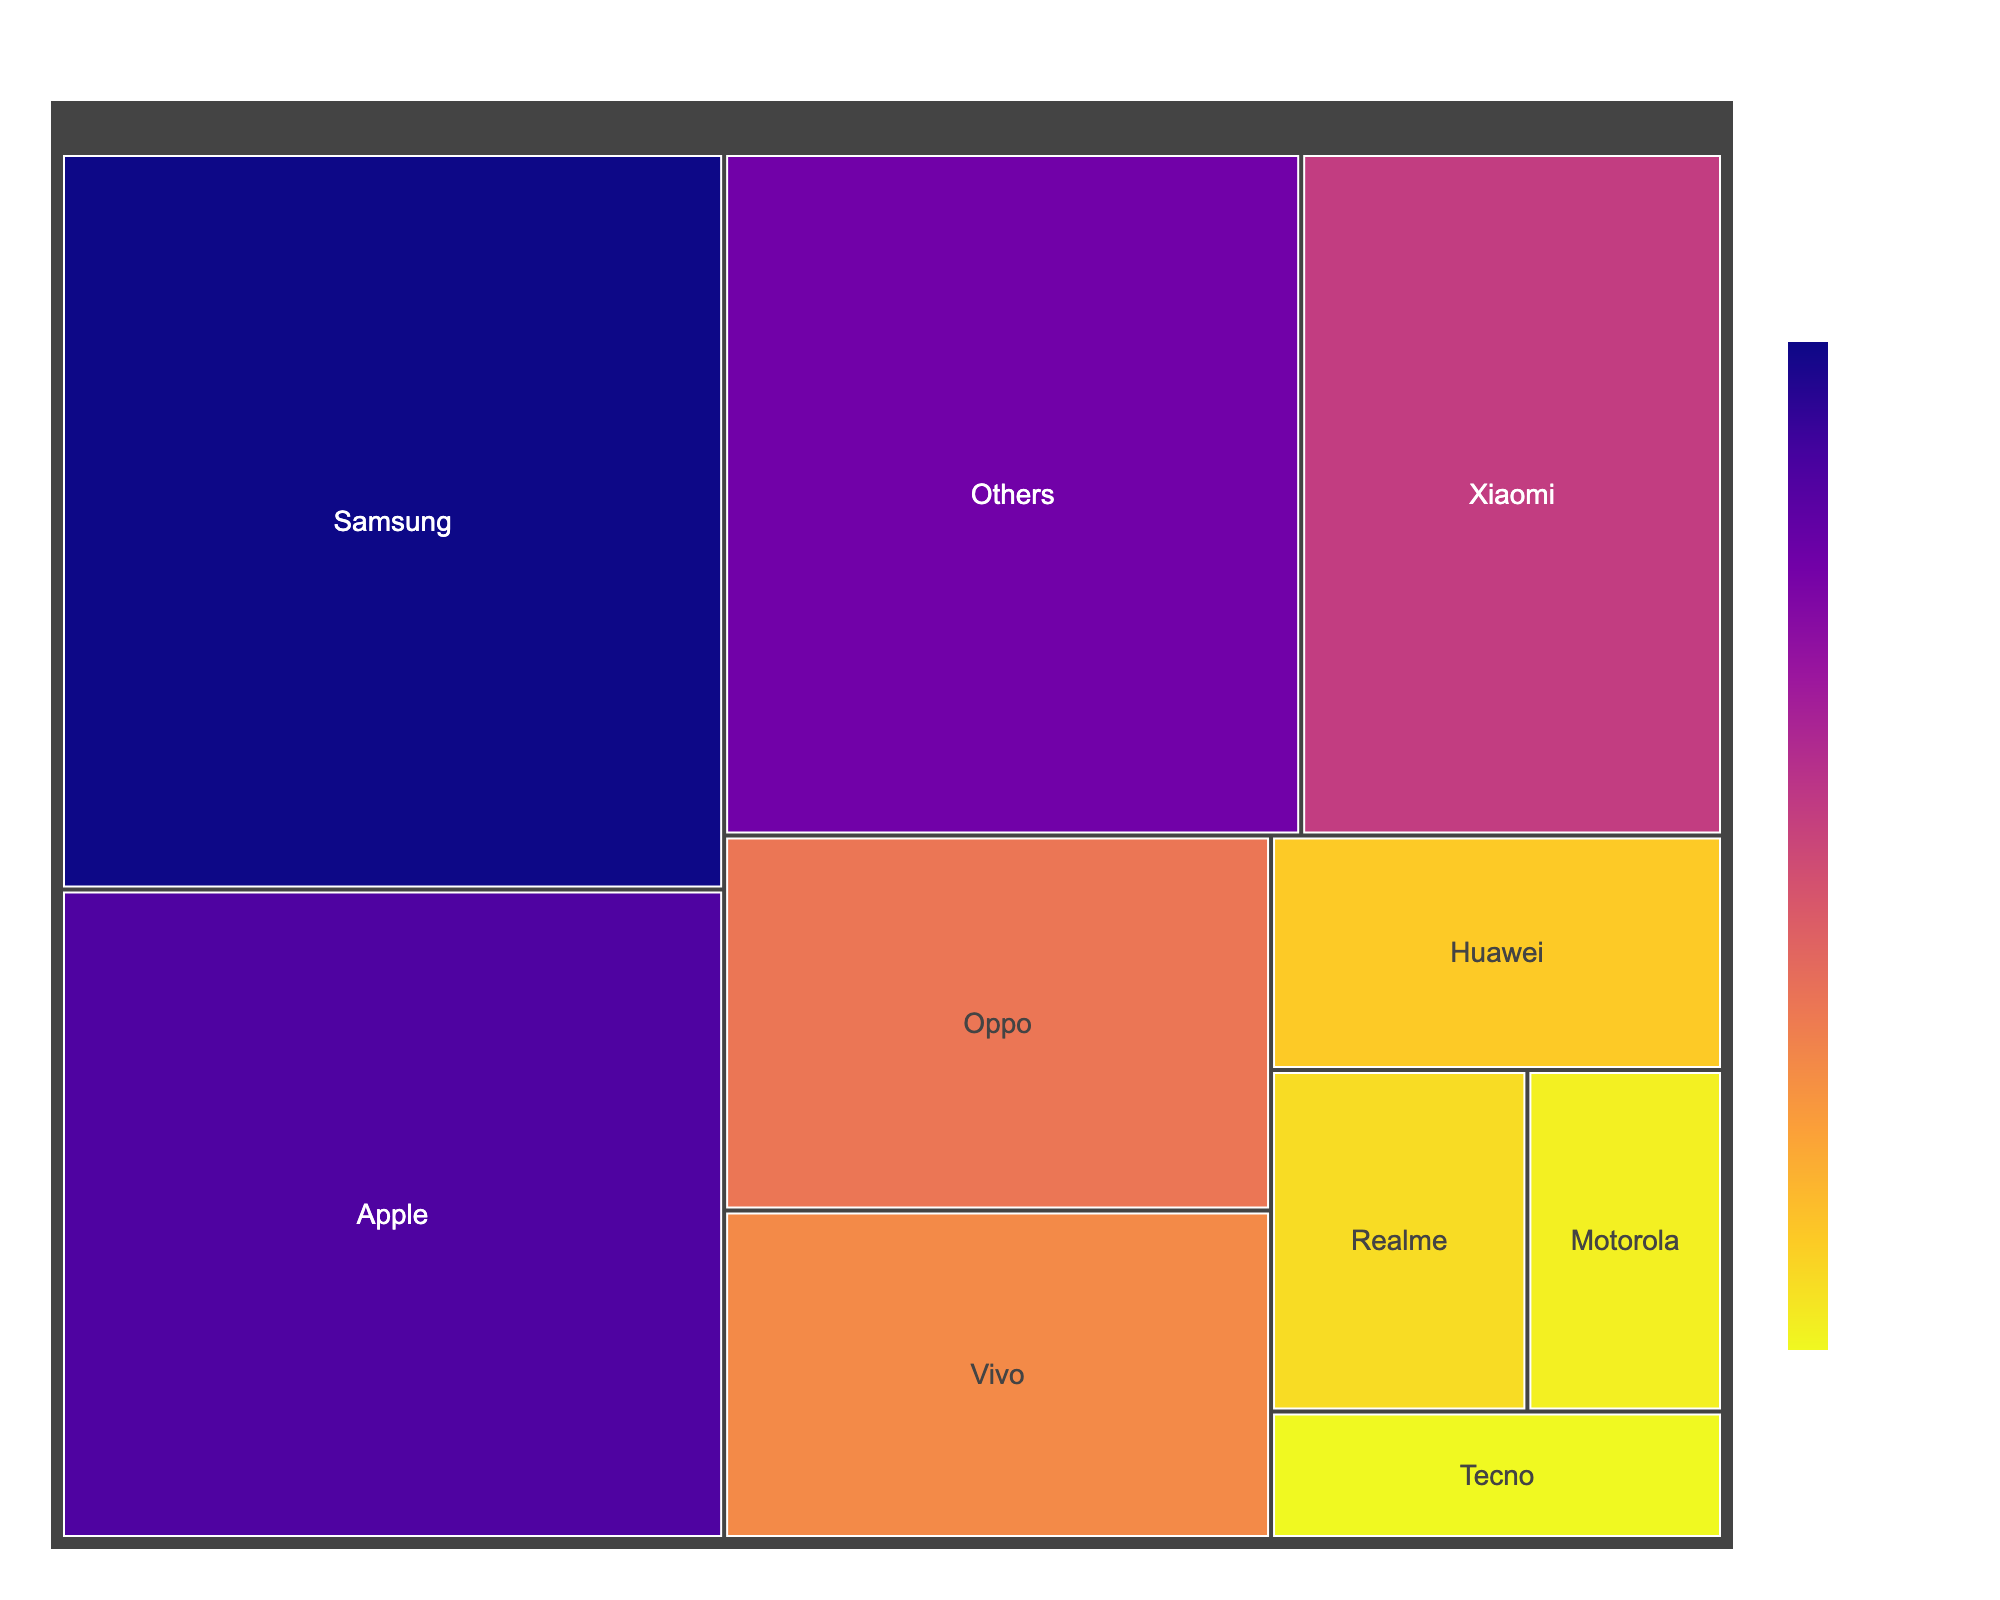What is the title of the Treemap? The title is typically displayed at the top of the figure. In this case, it is "Global Smartphone Market Share by Brand" which indicates the purpose and content of the Treemap.
Answer: Global Smartphone Market Share by Brand Which brand has the largest market share? To determine the largest market share, look for the largest section in the Treemap. The largest section corresponds to Samsung with a market share of 21.2%.
Answer: Samsung What is the combined market share of Samsung and Apple? Locate Samsung and Apple's sections in the Treemap and add their market shares together: 21.2% (Samsung) + 18.7% (Apple) = 39.9%.
Answer: 39.9% Which brand has a market share closest to 10%? To find the market share closest to 10%, check the values near that mark. Xiaomi is closest with a 12.5% market share.
Answer: Xiaomi Compare the market share of Oppo and Vivo. Which one is higher, and by how much? Locate the sections for Oppo and Vivo. Oppo has an 8.9% share, and Vivo has a 7.8% share. The difference is 8.9% - 7.8% = 1.1%, making Oppo's share higher by 1.1%.
Answer: Oppo by 1.1% What is the cumulative market share of brands with less than 5% market share each? Identify brands with less than 5% share: Huawei (4.6%), Realme (3.8%), Motorola (2.9%), Tecno (2.5%), and Others (17.1%). Sum these up: 4.6% + 3.8% + 2.9% + 2.5% + 17.1% = 30.9%.
Answer: 30.9% Which brand has the smallest market share among those listed? Look for the smallest section in the Treemap and identify the brand. Tecno has the smallest market share with 2.5%.
Answer: Tecno How many brands have a market share of more than 15%? Identify brands with more than 15% market share. Both Samsung (21.2%) and Apple (18.7%) meet this criterion. Count them: 2 brands.
Answer: 2 If the market share of "Others" is excluded, what is the new total percentage for the listed brands? To find the new total, subtract the "Others" share from 100%: 100% - 17.1% = 82.9%.
Answer: 82.9% How does the color scale help interpret the Treemap? The color scale, from Plasma_r, visually differentiates market shares where darker shades represent higher percentages and lighter shades indicate lower percentages, making it easier to compare at a glance.
Answer: Differentiates market shares by shade: darker=higher, lighter=lower 